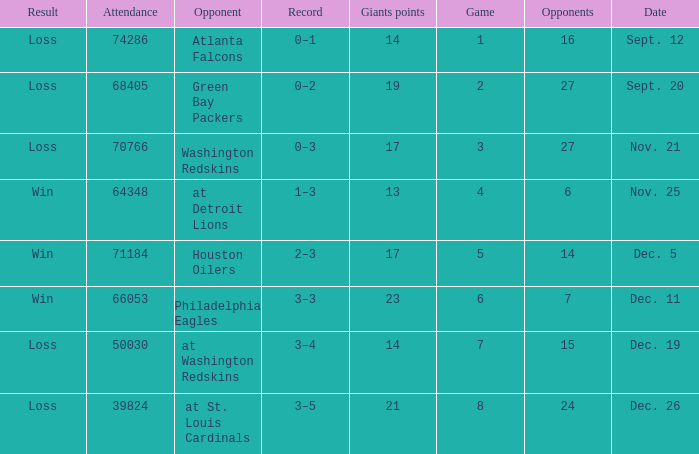What is the minimum number of opponents? 6.0. 